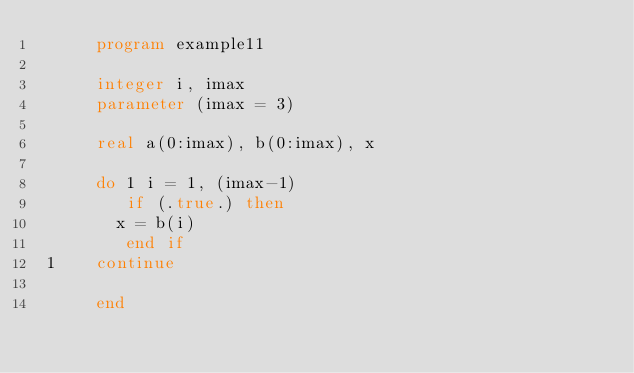Convert code to text. <code><loc_0><loc_0><loc_500><loc_500><_FORTRAN_>      program example11

      integer i, imax
      parameter (imax = 3)

      real a(0:imax), b(0:imax), x

      do 1 i = 1, (imax-1)
         if (.true.) then
        x = b(i)
         end if
 1    continue

      end
</code> 